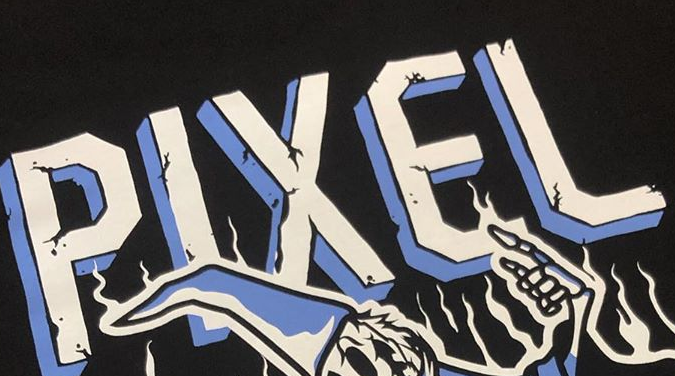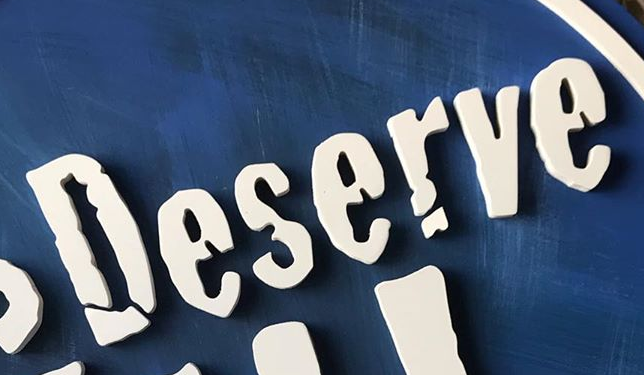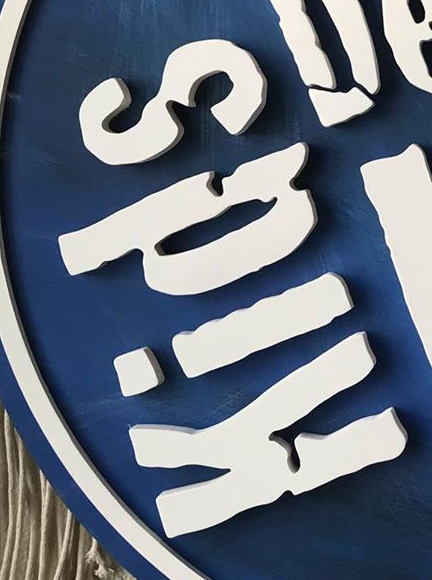Read the text content from these images in order, separated by a semicolon. PIXEL; Deserve; Kids 